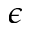Convert formula to latex. <formula><loc_0><loc_0><loc_500><loc_500>\epsilon</formula> 